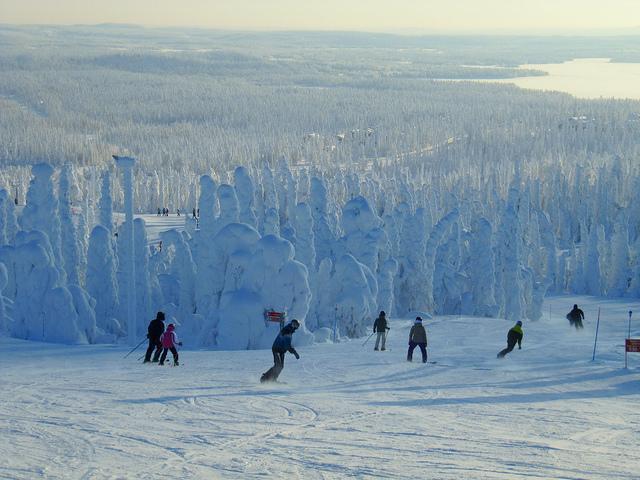How many people are in this picture?
Give a very brief answer. 7. 